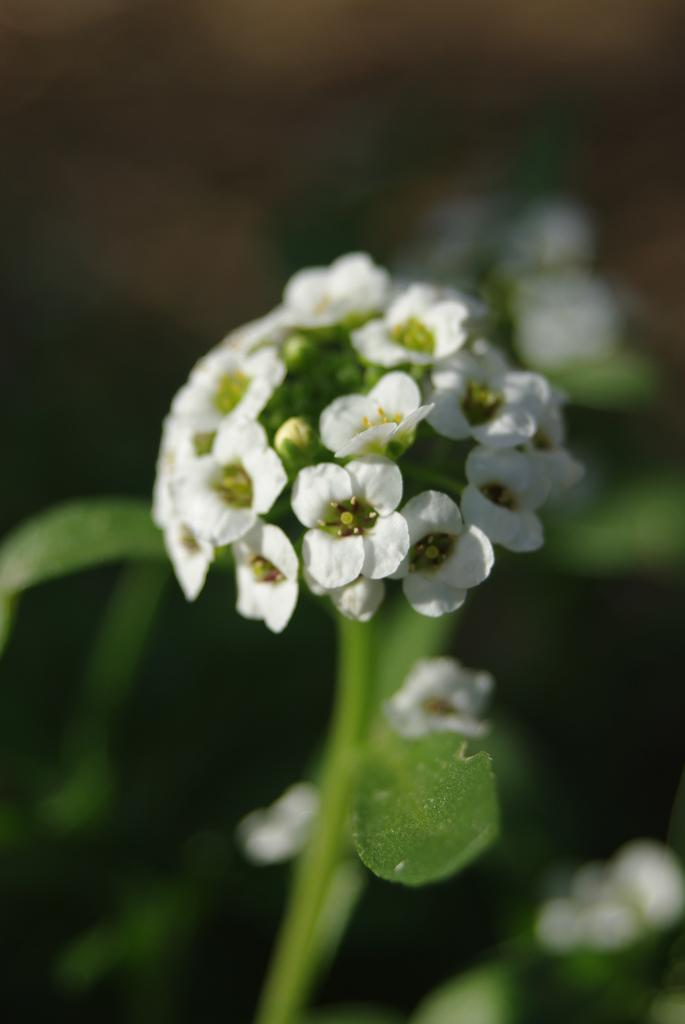What is present in the image? There are flowers in the image. Can you describe the background of the image? The background of the image is blurred. What type of ice can be seen melting on the owl's head in the image? There is no ice or owl present in the image; it features flowers with a blurred background. 